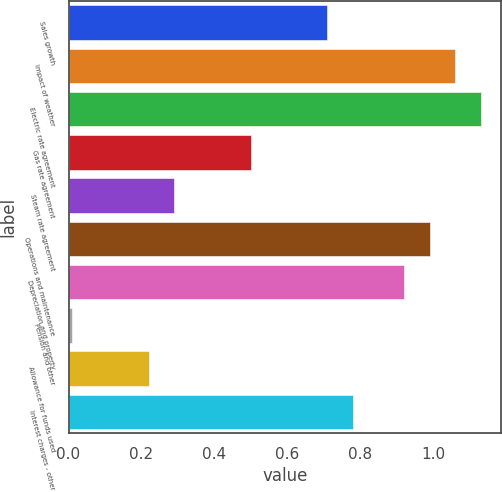<chart> <loc_0><loc_0><loc_500><loc_500><bar_chart><fcel>Sales growth<fcel>Impact of weather<fcel>Electric rate agreement<fcel>Gas rate agreement<fcel>Steam rate agreement<fcel>Operations and maintenance<fcel>Depreciation and property<fcel>Pension and other<fcel>Allowance for funds used<fcel>Interest charges - other<nl><fcel>0.71<fcel>1.06<fcel>1.13<fcel>0.5<fcel>0.29<fcel>0.99<fcel>0.92<fcel>0.01<fcel>0.22<fcel>0.78<nl></chart> 